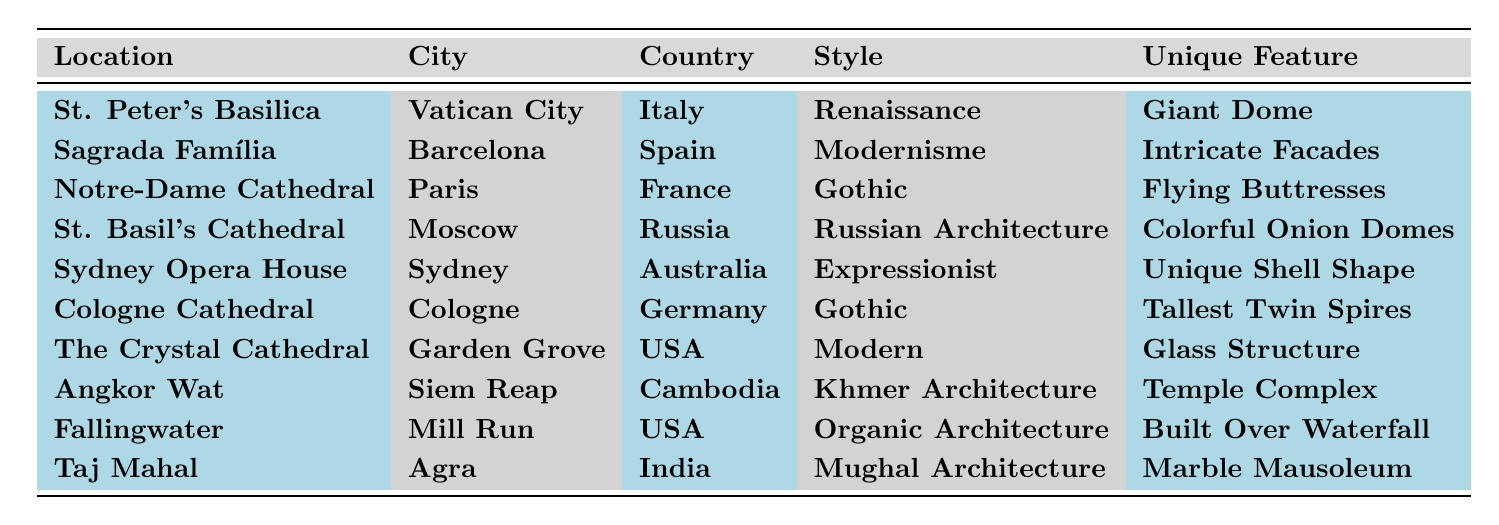What is the unique feature of the Sagrada Família? The table lists the unique features of each location. For the Sagrada Família, it specifies that the unique feature is "Intricate Facades."
Answer: Intricate Facades Which city is the St. Basil's Cathedral located in? The table explicitly states the city for each location. St. Basil's Cathedral is located in Moscow.
Answer: Moscow How many locations listed are classified as Gothic style? From the table, we see two locations identified as Gothic style: Notre-Dame Cathedral and Cologne Cathedral. Thus, there are 2 Gothic style locations.
Answer: 2 Is the unique feature of the Taj Mahal a Giant Dome? The table lists the unique feature of the Taj Mahal as "Marble Mausoleum," which is not a Giant Dome. Therefore, the statement is false.
Answer: No What style does the Sydney Opera House belong to? The table shows that the Sydney Opera House is categorized under the style "Expressionist."
Answer: Expressionist Which country features the largest number of locations listed? According to the table, there are 2 locations from the USA (The Crystal Cathedral and Fallingwater), 1 each from Italy, Spain, France, Russia, Australia, Germany, Cambodia, and India. The USA has the most listed.
Answer: USA What is the unique feature of Fallingwater? The unique feature of Fallingwater, as indicated in the table, is "Built Over Waterfall."
Answer: Built Over Waterfall Which architectural style has the most representation in this table? The table includes Gothic style with 2 entries and all others with 1 entry. Hence Gothic style has the most representation.
Answer: Gothic In which city is Angkor Wat located? The table clearly indicates that Angkor Wat is situated in Siem Reap.
Answer: Siem Reap Does the Crystal Cathedral feature a temple complex? The unique feature of the Crystal Cathedral is stated as "Glass Structure" in the table, so it does not have a temple complex.
Answer: No 